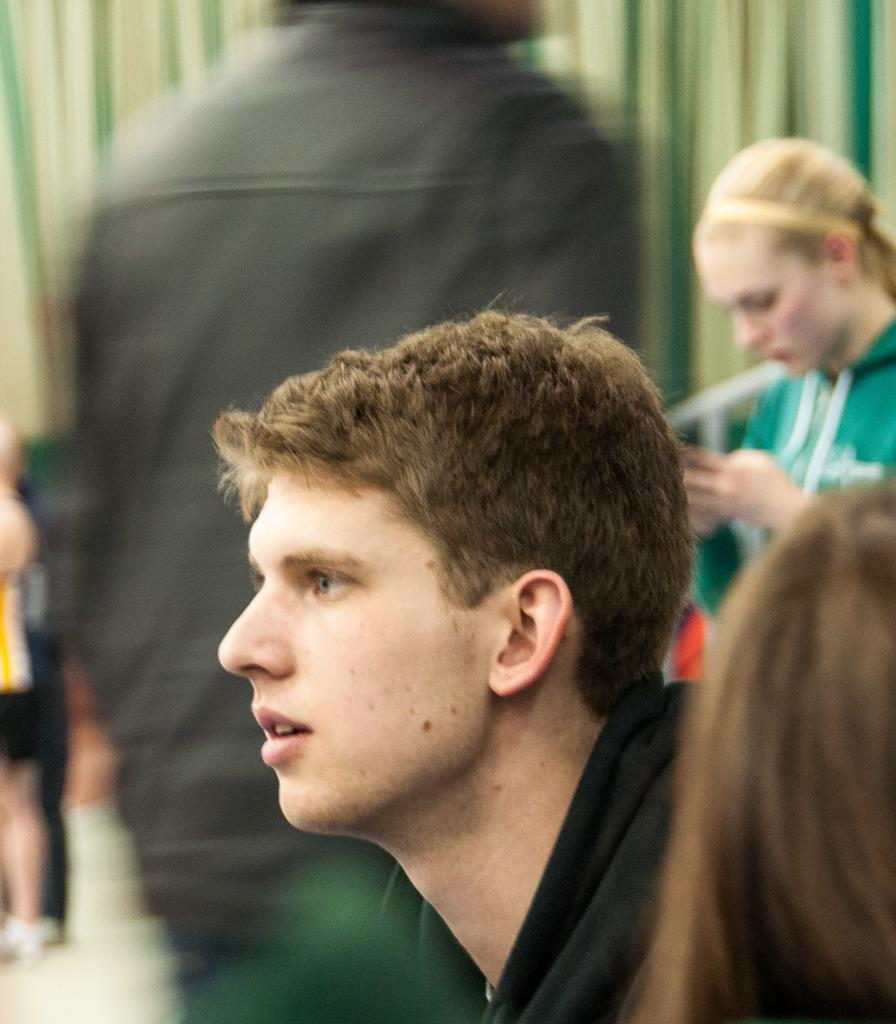What is the main subject of the image? The main subject of the image is a person's face. Are there any other people visible in the image? Yes, there are other people around the person's face. What type of arch can be seen in the background of the image? There is no arch visible in the image; it only features a person's face and other people around it. 